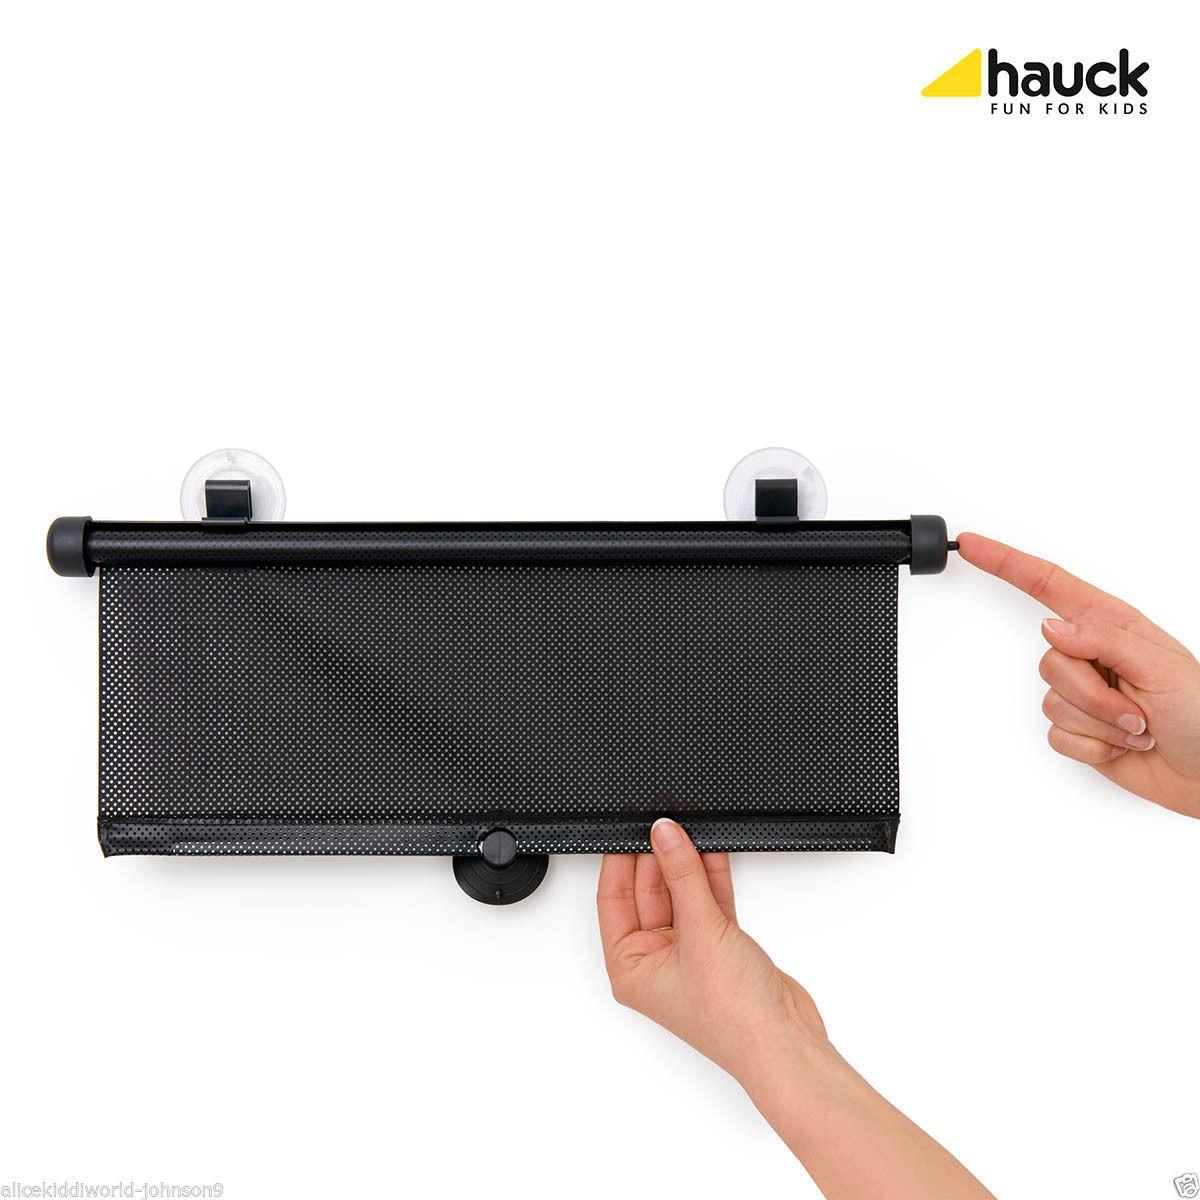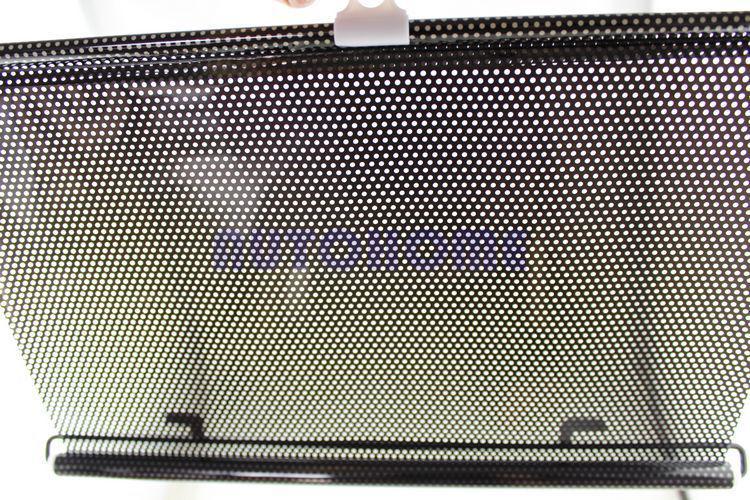The first image is the image on the left, the second image is the image on the right. For the images displayed, is the sentence "The right image shows the vehicle's interior with a shaded window." factually correct? Answer yes or no. No. 